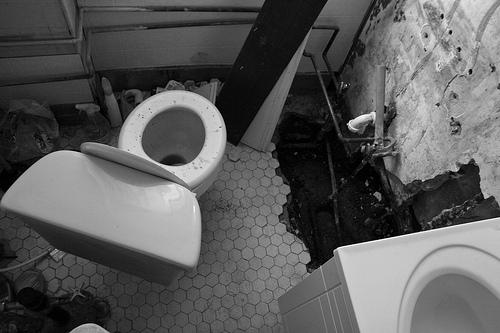Question: what color is the toilet?
Choices:
A. Green.
B. Gray.
C. White.
D. Blue.
Answer with the letter. Answer: C Question: what color is the wall?
Choices:
A. White.
B. Gray.
C. Blue.
D. Green.
Answer with the letter. Answer: B Question: where was this photo taken?
Choices:
A. On the lawn.
B. Near the window.
C. An abandoned house.
D. In the yard.
Answer with the letter. Answer: C Question: why is this photo illuminated?
Choices:
A. The sun.
B. Window.
C. The lamp.
D. The light.
Answer with the letter. Answer: B Question: who is the subject of the photo?
Choices:
A. My sister.
B. My brother.
C. Toilet.
D. My spouse.
Answer with the letter. Answer: C 